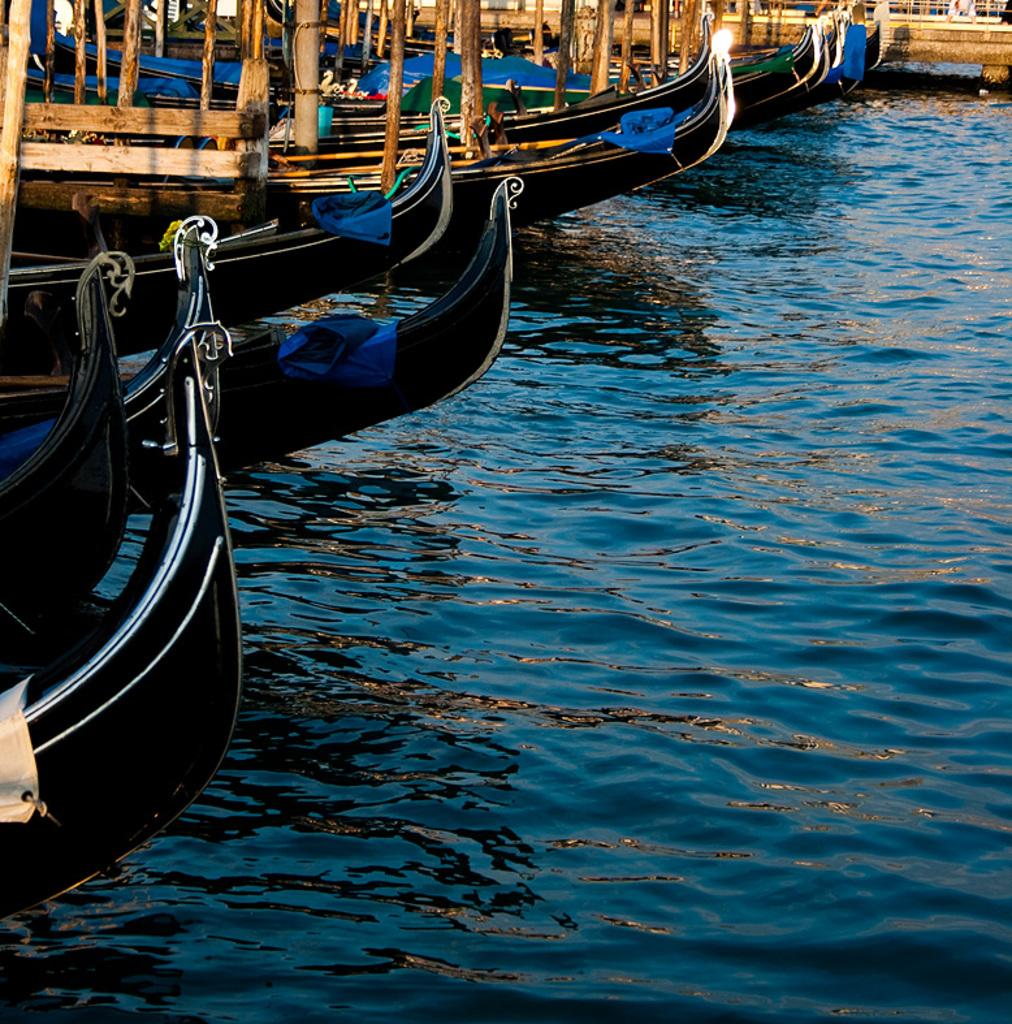What is the main subject of the image? The main subject of the image is boats. Where are the boats located? The boats are on the water. What can be seen on the boats? There are wooden poles on the boats. What type of coat is the boat wearing in the image? There is no coat present in the image, as boats do not wear clothing. 